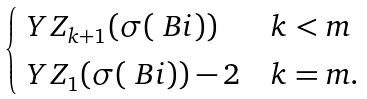Convert formula to latex. <formula><loc_0><loc_0><loc_500><loc_500>\begin{cases} \ Y Z _ { k + 1 } ( \sigma ( \ B i ) ) & k < m \\ \ Y Z _ { 1 } ( \sigma ( \ B i ) ) - 2 & k = m . \end{cases}</formula> 